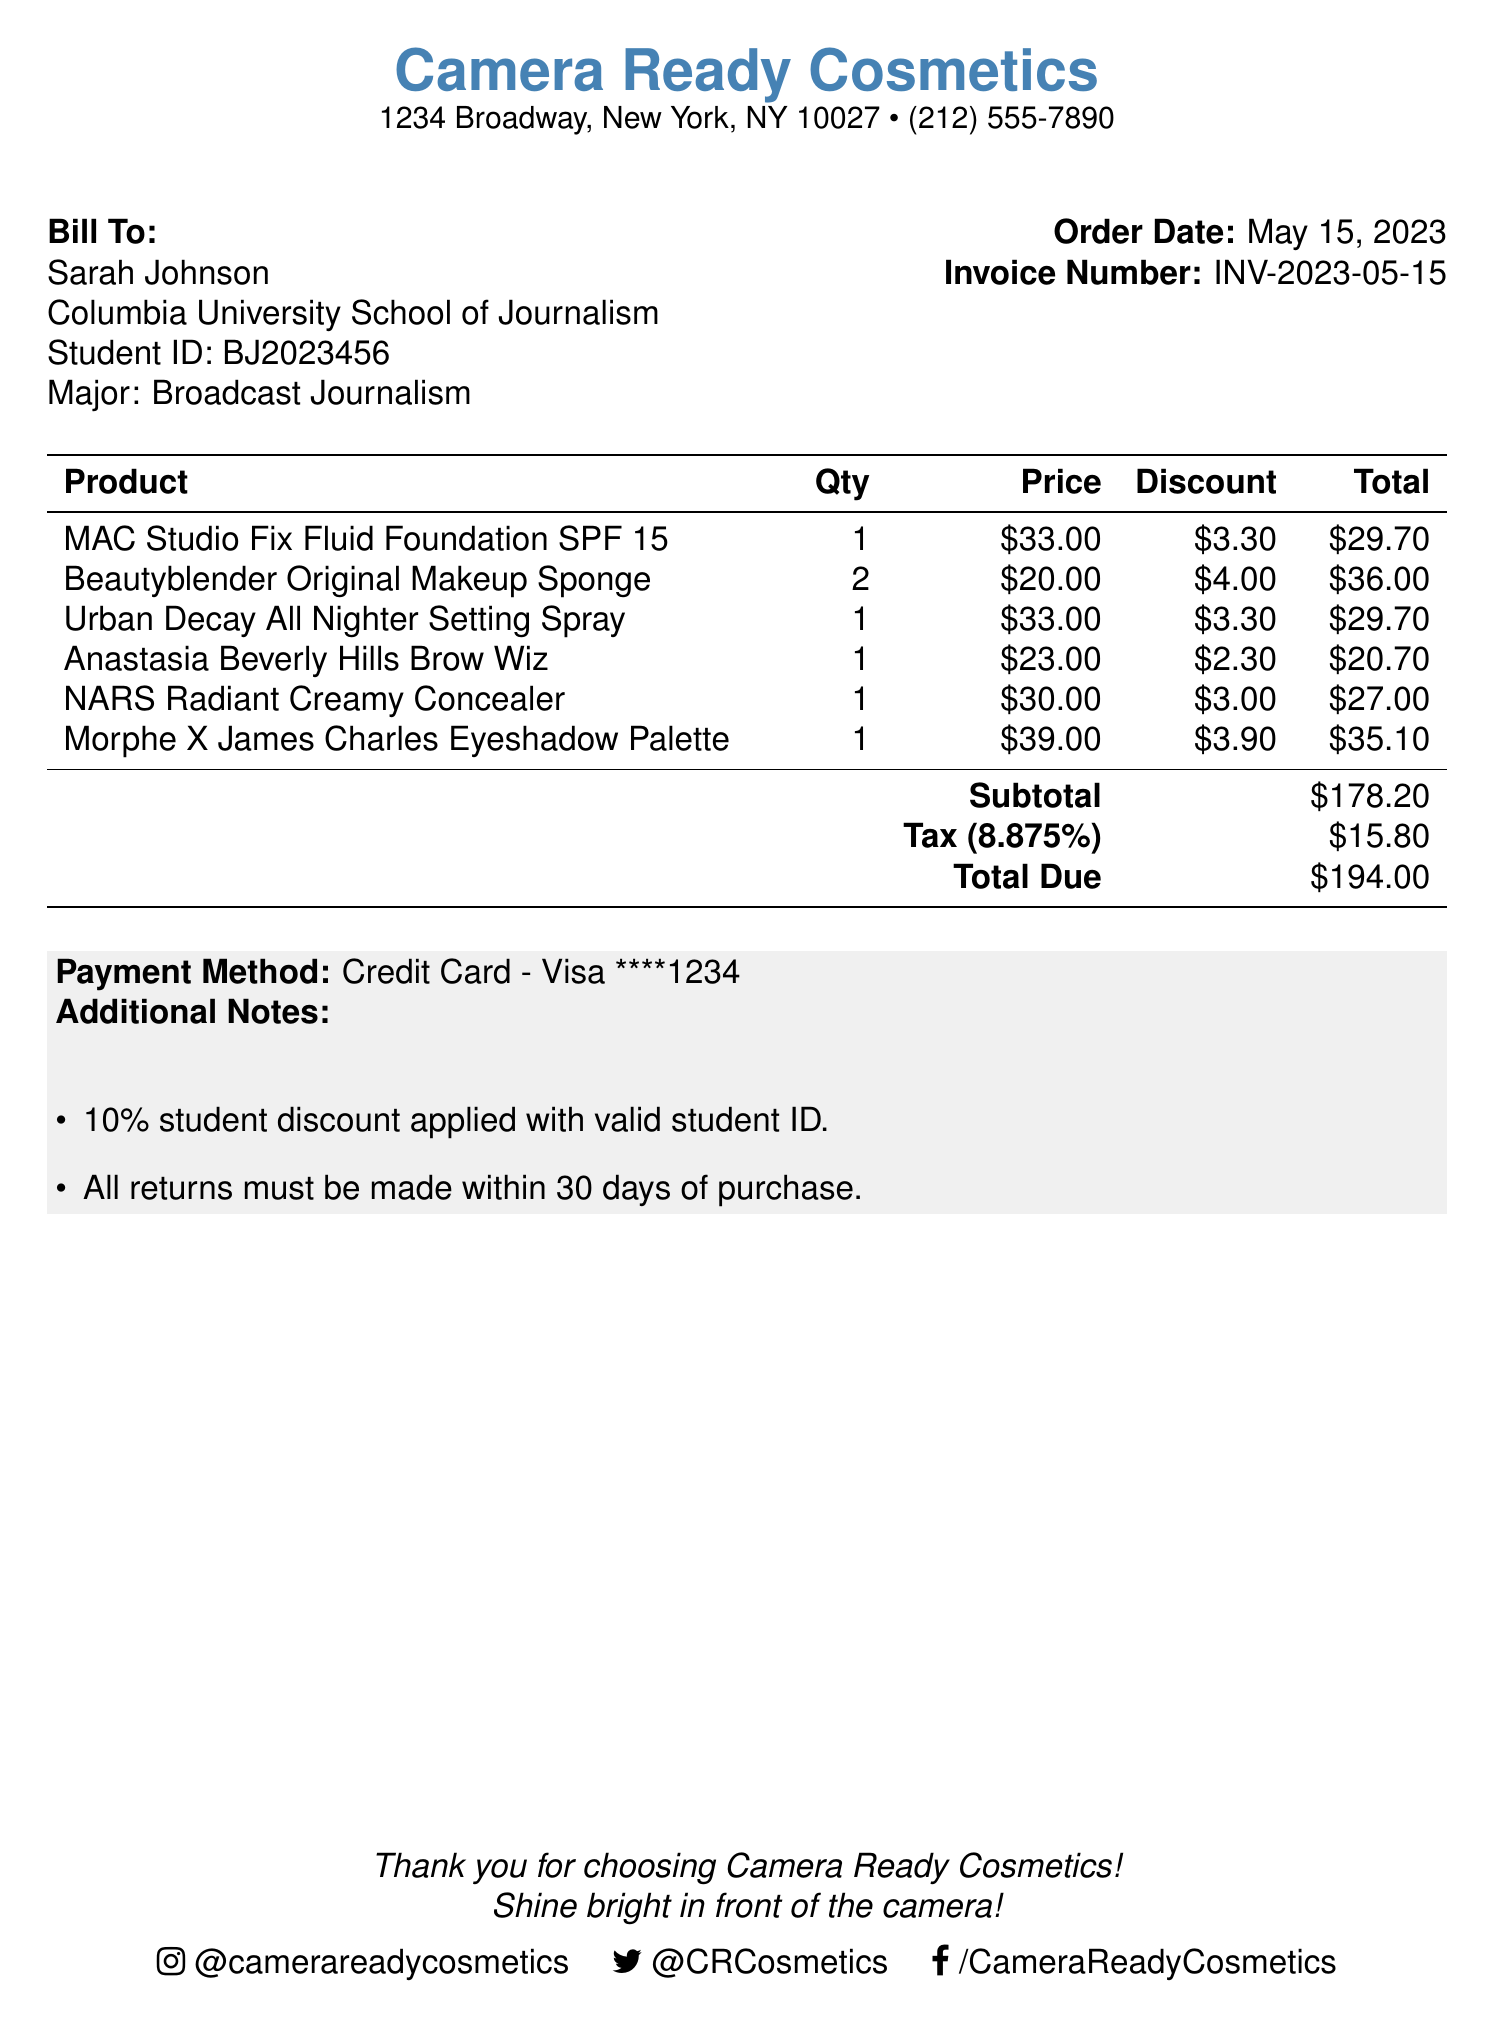What is the name of the student? The bill lists the name of the student as Sarah Johnson.
Answer: Sarah Johnson What is the subtotal amount? The subtotal is presented as the sum of all product totals before tax, which is $178.20.
Answer: $178.20 How much is the student discount applied? The document mentions a 10% student discount applied with a valid student ID, which is reflected in the pricing.
Answer: 10% What is the total due? The document states the total due after tax and discounts as $194.00.
Answer: $194.00 How many Beautyblender sponges were purchased? The quantity of Beautyblender Original Makeup Sponges purchased is given as 2 in the invoice.
Answer: 2 What is the invoice number? The invoice number is specifically noted as INV-2023-05-15 in the document.
Answer: INV-2023-05-15 What is the applicable tax rate? The tax rate applied in the document is listed as 8.875%.
Answer: 8.875% Where was the purchase made? The purchase was made at Camera Ready Cosmetics, as identified in the document header.
Answer: Camera Ready Cosmetics What method of payment was used? The document indicates that the payment method used was a Credit Card (Visa).
Answer: Credit Card - Visa What is the return policy mentioned? The document states that all returns must be made within 30 days of purchase.
Answer: 30 days 